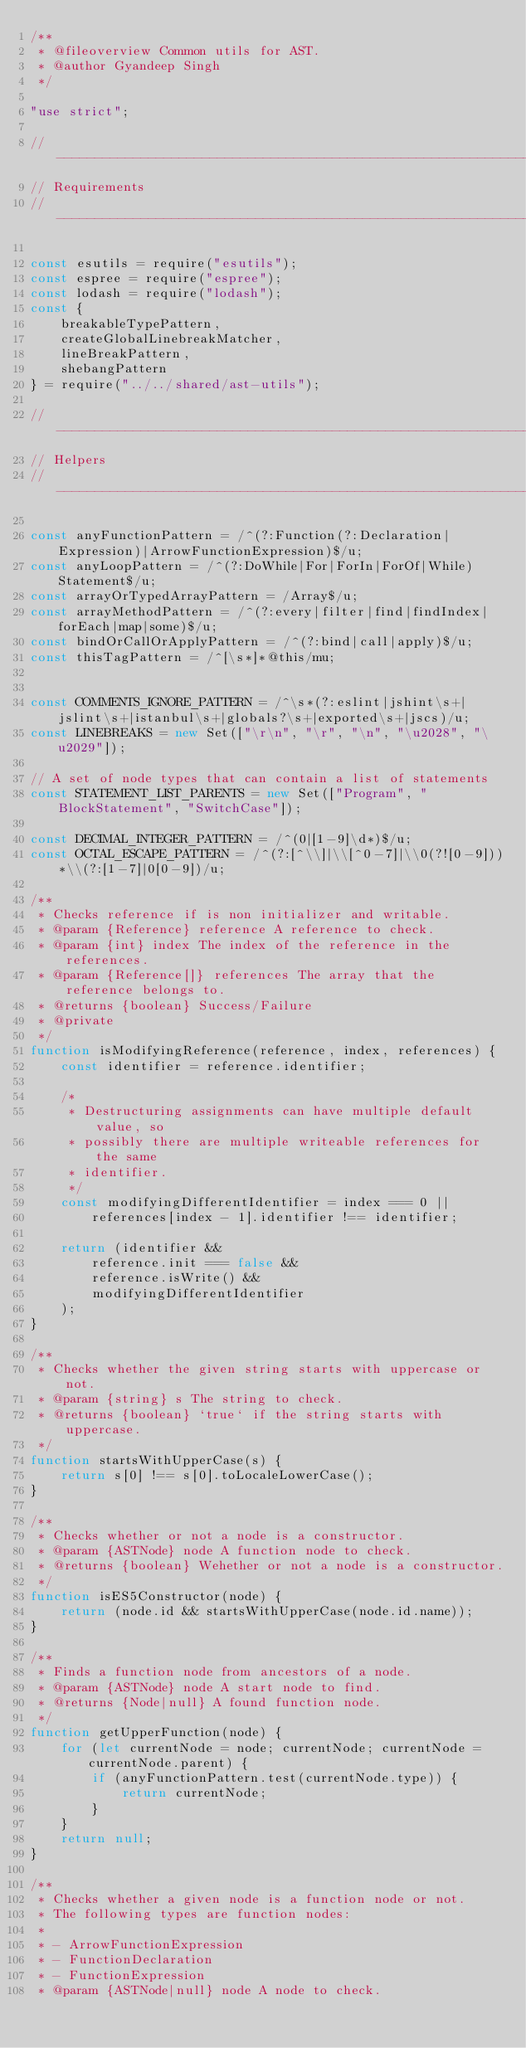<code> <loc_0><loc_0><loc_500><loc_500><_JavaScript_>/**
 * @fileoverview Common utils for AST.
 * @author Gyandeep Singh
 */

"use strict";

//------------------------------------------------------------------------------
// Requirements
//------------------------------------------------------------------------------

const esutils = require("esutils");
const espree = require("espree");
const lodash = require("lodash");
const {
    breakableTypePattern,
    createGlobalLinebreakMatcher,
    lineBreakPattern,
    shebangPattern
} = require("../../shared/ast-utils");

//------------------------------------------------------------------------------
// Helpers
//------------------------------------------------------------------------------

const anyFunctionPattern = /^(?:Function(?:Declaration|Expression)|ArrowFunctionExpression)$/u;
const anyLoopPattern = /^(?:DoWhile|For|ForIn|ForOf|While)Statement$/u;
const arrayOrTypedArrayPattern = /Array$/u;
const arrayMethodPattern = /^(?:every|filter|find|findIndex|forEach|map|some)$/u;
const bindOrCallOrApplyPattern = /^(?:bind|call|apply)$/u;
const thisTagPattern = /^[\s*]*@this/mu;


const COMMENTS_IGNORE_PATTERN = /^\s*(?:eslint|jshint\s+|jslint\s+|istanbul\s+|globals?\s+|exported\s+|jscs)/u;
const LINEBREAKS = new Set(["\r\n", "\r", "\n", "\u2028", "\u2029"]);

// A set of node types that can contain a list of statements
const STATEMENT_LIST_PARENTS = new Set(["Program", "BlockStatement", "SwitchCase"]);

const DECIMAL_INTEGER_PATTERN = /^(0|[1-9]\d*)$/u;
const OCTAL_ESCAPE_PATTERN = /^(?:[^\\]|\\[^0-7]|\\0(?![0-9]))*\\(?:[1-7]|0[0-9])/u;

/**
 * Checks reference if is non initializer and writable.
 * @param {Reference} reference A reference to check.
 * @param {int} index The index of the reference in the references.
 * @param {Reference[]} references The array that the reference belongs to.
 * @returns {boolean} Success/Failure
 * @private
 */
function isModifyingReference(reference, index, references) {
    const identifier = reference.identifier;

    /*
     * Destructuring assignments can have multiple default value, so
     * possibly there are multiple writeable references for the same
     * identifier.
     */
    const modifyingDifferentIdentifier = index === 0 ||
        references[index - 1].identifier !== identifier;

    return (identifier &&
        reference.init === false &&
        reference.isWrite() &&
        modifyingDifferentIdentifier
    );
}

/**
 * Checks whether the given string starts with uppercase or not.
 * @param {string} s The string to check.
 * @returns {boolean} `true` if the string starts with uppercase.
 */
function startsWithUpperCase(s) {
    return s[0] !== s[0].toLocaleLowerCase();
}

/**
 * Checks whether or not a node is a constructor.
 * @param {ASTNode} node A function node to check.
 * @returns {boolean} Wehether or not a node is a constructor.
 */
function isES5Constructor(node) {
    return (node.id && startsWithUpperCase(node.id.name));
}

/**
 * Finds a function node from ancestors of a node.
 * @param {ASTNode} node A start node to find.
 * @returns {Node|null} A found function node.
 */
function getUpperFunction(node) {
    for (let currentNode = node; currentNode; currentNode = currentNode.parent) {
        if (anyFunctionPattern.test(currentNode.type)) {
            return currentNode;
        }
    }
    return null;
}

/**
 * Checks whether a given node is a function node or not.
 * The following types are function nodes:
 *
 * - ArrowFunctionExpression
 * - FunctionDeclaration
 * - FunctionExpression
 * @param {ASTNode|null} node A node to check.</code> 